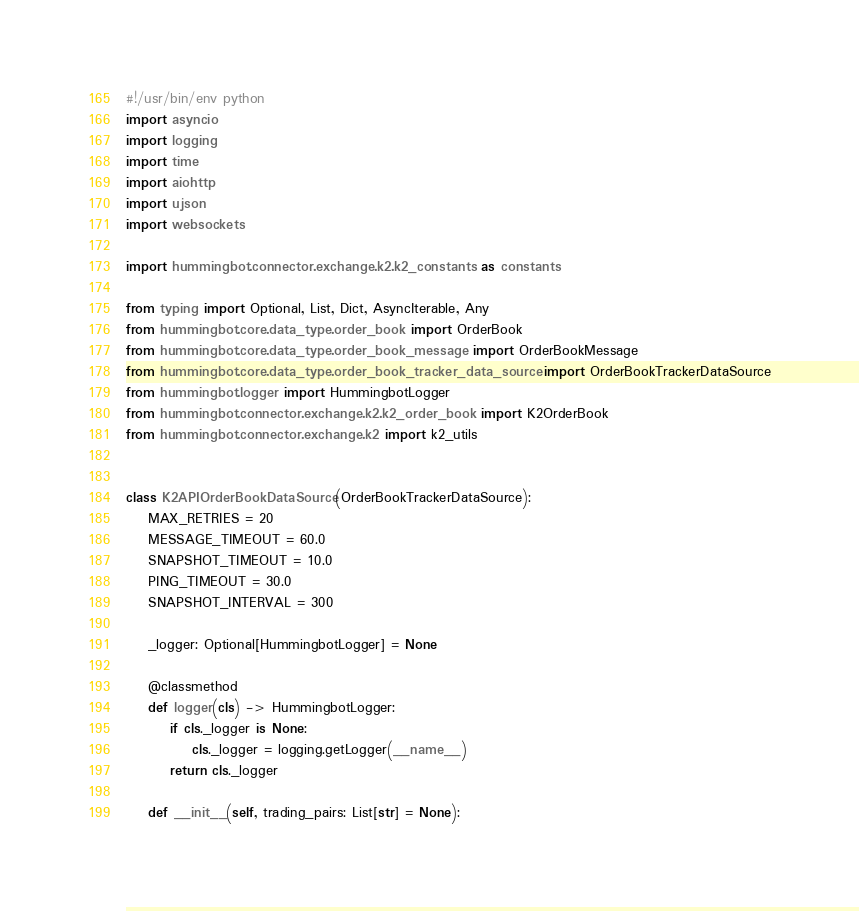<code> <loc_0><loc_0><loc_500><loc_500><_Python_>#!/usr/bin/env python
import asyncio
import logging
import time
import aiohttp
import ujson
import websockets

import hummingbot.connector.exchange.k2.k2_constants as constants

from typing import Optional, List, Dict, AsyncIterable, Any
from hummingbot.core.data_type.order_book import OrderBook
from hummingbot.core.data_type.order_book_message import OrderBookMessage
from hummingbot.core.data_type.order_book_tracker_data_source import OrderBookTrackerDataSource
from hummingbot.logger import HummingbotLogger
from hummingbot.connector.exchange.k2.k2_order_book import K2OrderBook
from hummingbot.connector.exchange.k2 import k2_utils


class K2APIOrderBookDataSource(OrderBookTrackerDataSource):
    MAX_RETRIES = 20
    MESSAGE_TIMEOUT = 60.0
    SNAPSHOT_TIMEOUT = 10.0
    PING_TIMEOUT = 30.0
    SNAPSHOT_INTERVAL = 300

    _logger: Optional[HummingbotLogger] = None

    @classmethod
    def logger(cls) -> HummingbotLogger:
        if cls._logger is None:
            cls._logger = logging.getLogger(__name__)
        return cls._logger

    def __init__(self, trading_pairs: List[str] = None):</code> 